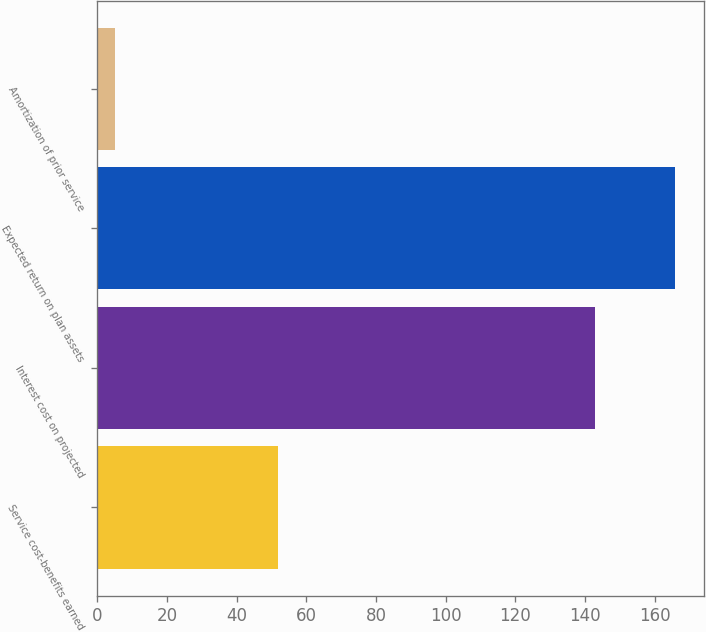<chart> <loc_0><loc_0><loc_500><loc_500><bar_chart><fcel>Service cost-benefits earned<fcel>Interest cost on projected<fcel>Expected return on plan assets<fcel>Amortization of prior service<nl><fcel>52<fcel>143<fcel>166<fcel>5<nl></chart> 